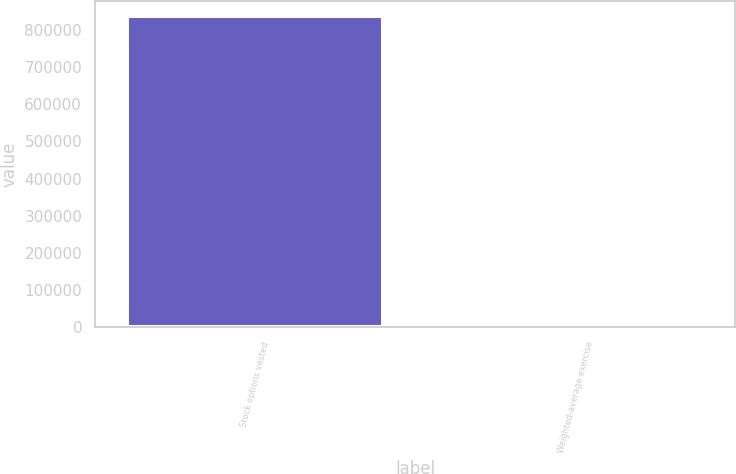<chart> <loc_0><loc_0><loc_500><loc_500><bar_chart><fcel>Stock options vested<fcel>Weighted-average exercise<nl><fcel>835982<fcel>47.21<nl></chart> 